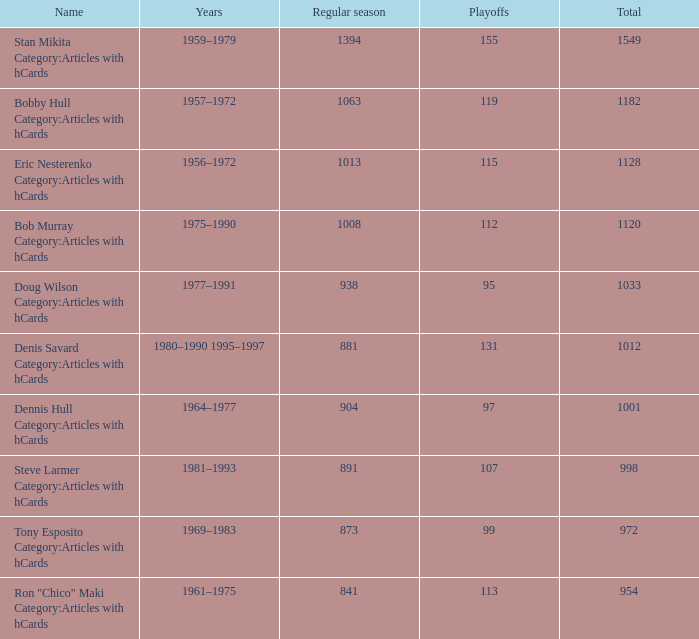How many times greater is the regular season with 1063 games compared to 119 playoff games? 0.0. 